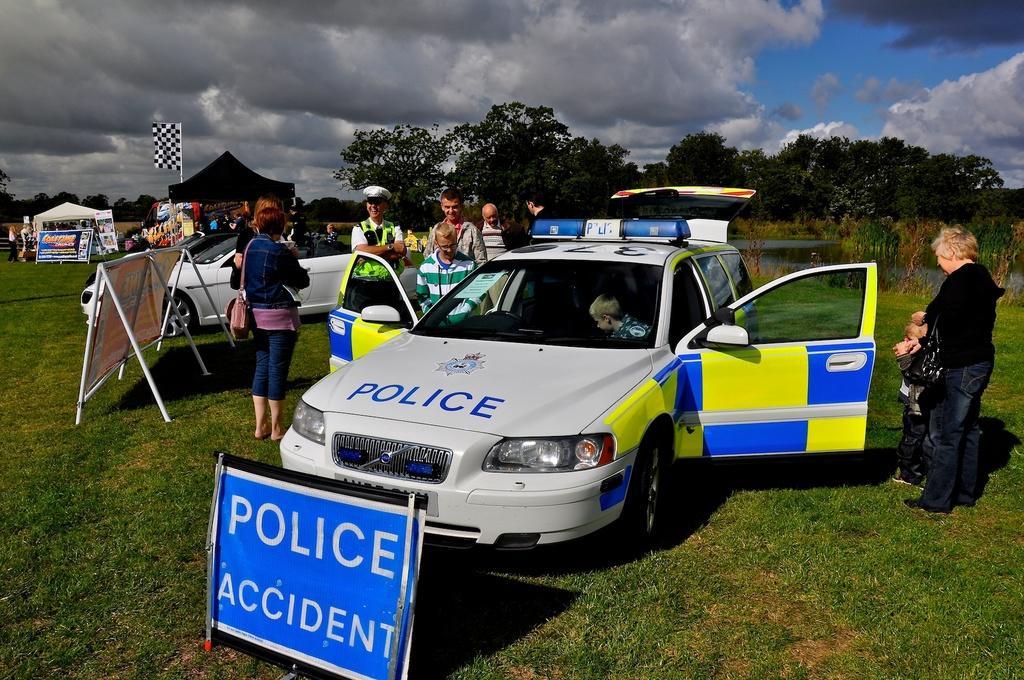In one or two sentences, can you explain what this image depicts? In this image there is the sky towards the top of the image, there are clouds in the sky, there are trees, there are tents, there is a pole, there is a flag, there are boards, there is text on the boards, there are two cars, there is water, there is grass towards the bottom of the image, there are a group of persons standing on the grass, there is a boy inside the car. 